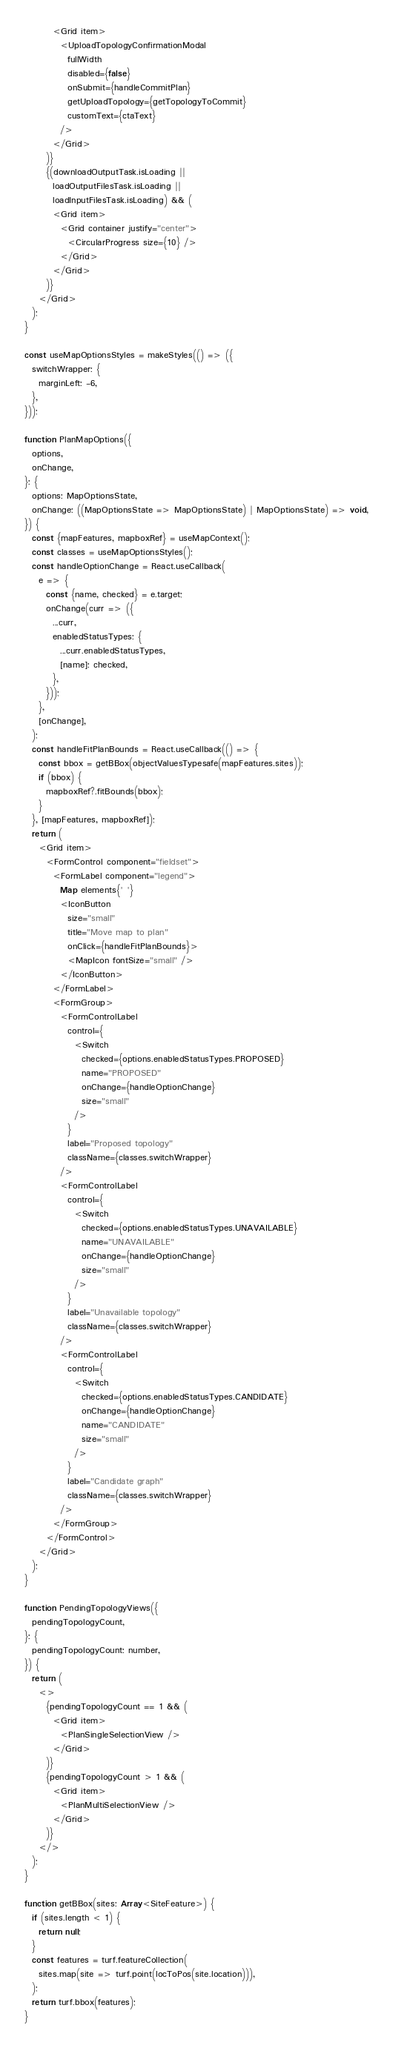<code> <loc_0><loc_0><loc_500><loc_500><_JavaScript_>        <Grid item>
          <UploadTopologyConfirmationModal
            fullWidth
            disabled={false}
            onSubmit={handleCommitPlan}
            getUploadTopology={getTopologyToCommit}
            customText={ctaText}
          />
        </Grid>
      )}
      {(downloadOutputTask.isLoading ||
        loadOutputFilesTask.isLoading ||
        loadInputFilesTask.isLoading) && (
        <Grid item>
          <Grid container justify="center">
            <CircularProgress size={10} />
          </Grid>
        </Grid>
      )}
    </Grid>
  );
}

const useMapOptionsStyles = makeStyles(() => ({
  switchWrapper: {
    marginLeft: -6,
  },
}));

function PlanMapOptions({
  options,
  onChange,
}: {
  options: MapOptionsState,
  onChange: ((MapOptionsState => MapOptionsState) | MapOptionsState) => void,
}) {
  const {mapFeatures, mapboxRef} = useMapContext();
  const classes = useMapOptionsStyles();
  const handleOptionChange = React.useCallback(
    e => {
      const {name, checked} = e.target;
      onChange(curr => ({
        ...curr,
        enabledStatusTypes: {
          ...curr.enabledStatusTypes,
          [name]: checked,
        },
      }));
    },
    [onChange],
  );
  const handleFitPlanBounds = React.useCallback(() => {
    const bbox = getBBox(objectValuesTypesafe(mapFeatures.sites));
    if (bbox) {
      mapboxRef?.fitBounds(bbox);
    }
  }, [mapFeatures, mapboxRef]);
  return (
    <Grid item>
      <FormControl component="fieldset">
        <FormLabel component="legend">
          Map elements{' '}
          <IconButton
            size="small"
            title="Move map to plan"
            onClick={handleFitPlanBounds}>
            <MapIcon fontSize="small" />
          </IconButton>
        </FormLabel>
        <FormGroup>
          <FormControlLabel
            control={
              <Switch
                checked={options.enabledStatusTypes.PROPOSED}
                name="PROPOSED"
                onChange={handleOptionChange}
                size="small"
              />
            }
            label="Proposed topology"
            className={classes.switchWrapper}
          />
          <FormControlLabel
            control={
              <Switch
                checked={options.enabledStatusTypes.UNAVAILABLE}
                name="UNAVAILABLE"
                onChange={handleOptionChange}
                size="small"
              />
            }
            label="Unavailable topology"
            className={classes.switchWrapper}
          />
          <FormControlLabel
            control={
              <Switch
                checked={options.enabledStatusTypes.CANDIDATE}
                onChange={handleOptionChange}
                name="CANDIDATE"
                size="small"
              />
            }
            label="Candidate graph"
            className={classes.switchWrapper}
          />
        </FormGroup>
      </FormControl>
    </Grid>
  );
}

function PendingTopologyViews({
  pendingTopologyCount,
}: {
  pendingTopologyCount: number,
}) {
  return (
    <>
      {pendingTopologyCount == 1 && (
        <Grid item>
          <PlanSingleSelectionView />
        </Grid>
      )}
      {pendingTopologyCount > 1 && (
        <Grid item>
          <PlanMultiSelectionView />
        </Grid>
      )}
    </>
  );
}

function getBBox(sites: Array<SiteFeature>) {
  if (sites.length < 1) {
    return null;
  }
  const features = turf.featureCollection(
    sites.map(site => turf.point(locToPos(site.location))),
  );
  return turf.bbox(features);
}
</code> 